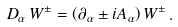Convert formula to latex. <formula><loc_0><loc_0><loc_500><loc_500>D _ { \alpha } \, W ^ { \pm } = \left ( \partial _ { \alpha } \pm i A _ { \alpha } \right ) W ^ { \pm } \, .</formula> 